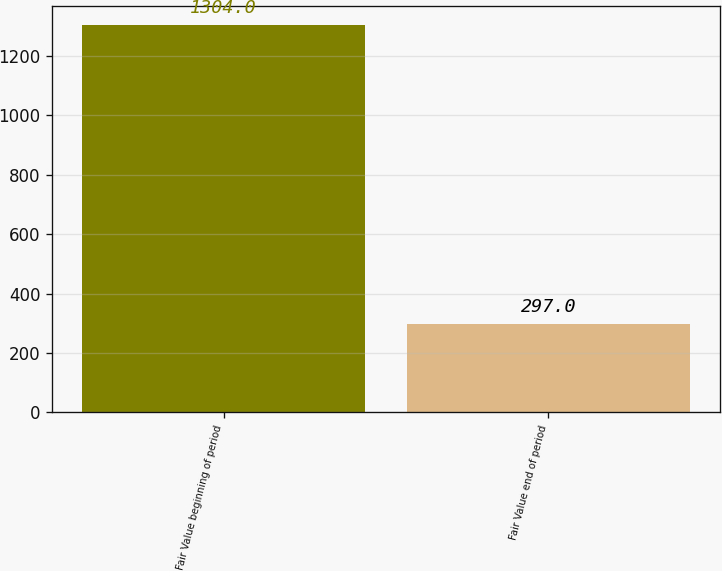<chart> <loc_0><loc_0><loc_500><loc_500><bar_chart><fcel>Fair Value beginning of period<fcel>Fair Value end of period<nl><fcel>1304<fcel>297<nl></chart> 